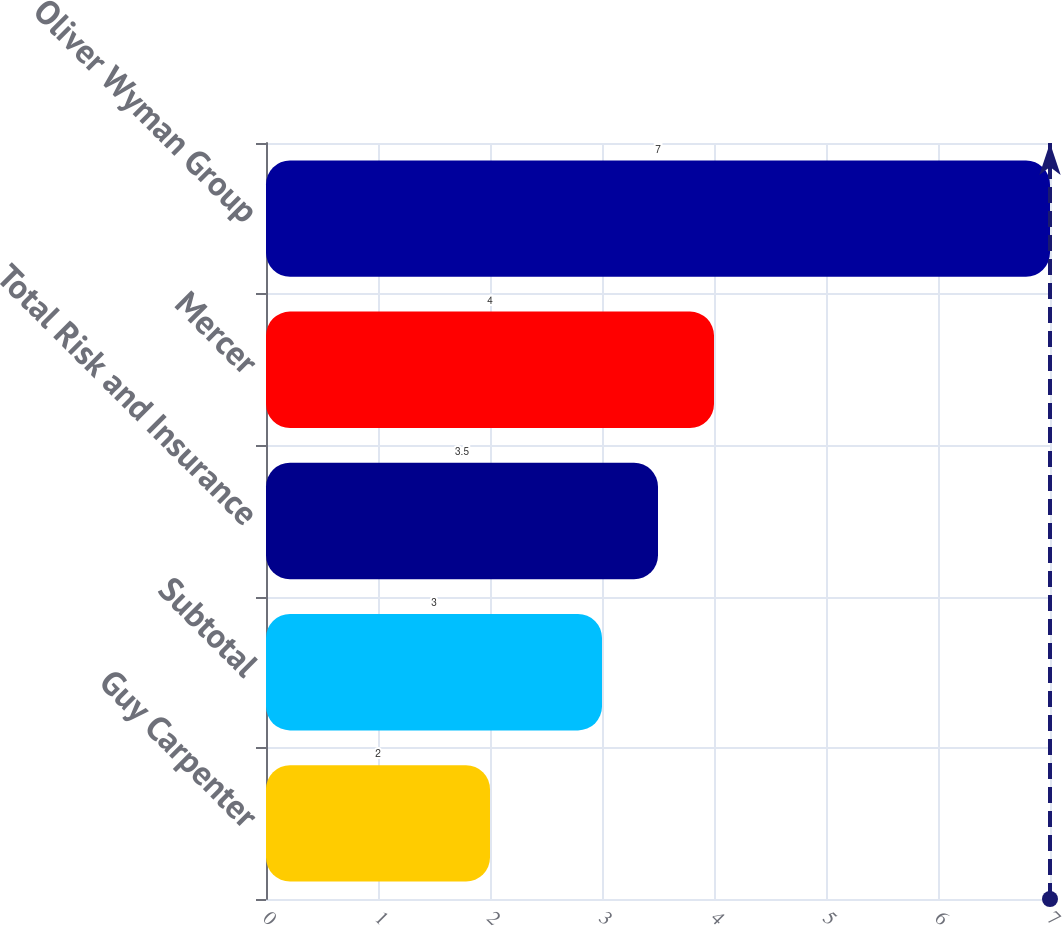Convert chart. <chart><loc_0><loc_0><loc_500><loc_500><bar_chart><fcel>Guy Carpenter<fcel>Subtotal<fcel>Total Risk and Insurance<fcel>Mercer<fcel>Oliver Wyman Group<nl><fcel>2<fcel>3<fcel>3.5<fcel>4<fcel>7<nl></chart> 